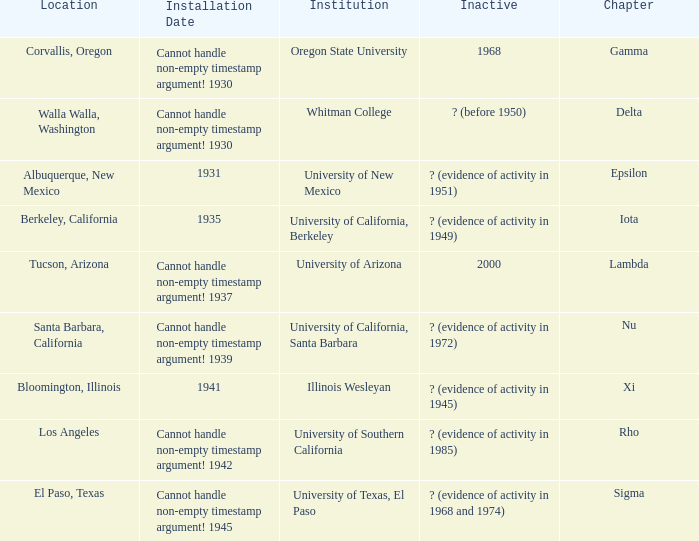What is the chapter for Illinois Wesleyan?  Xi. 